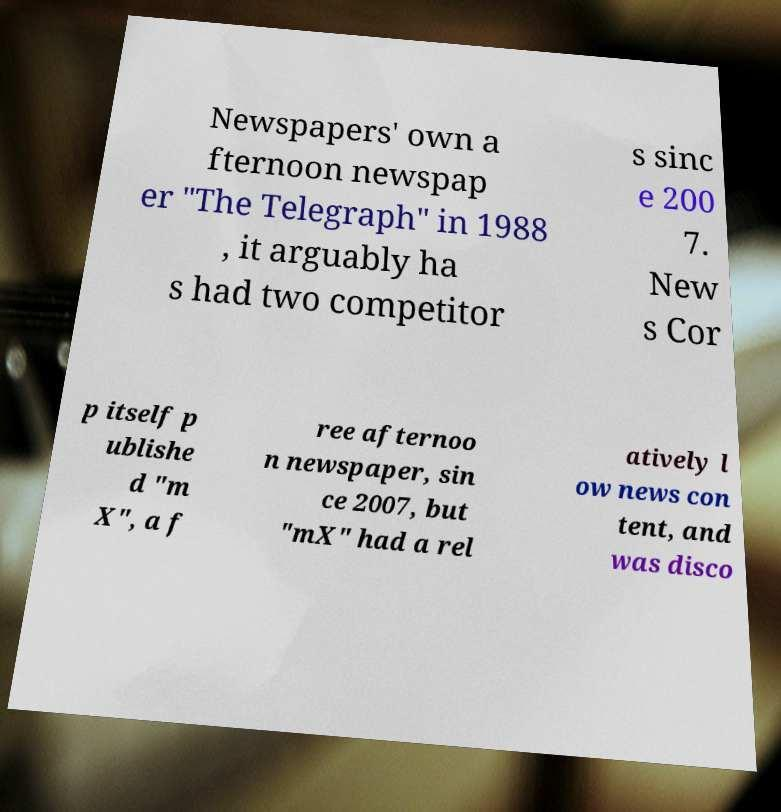Can you read and provide the text displayed in the image?This photo seems to have some interesting text. Can you extract and type it out for me? Newspapers' own a fternoon newspap er "The Telegraph" in 1988 , it arguably ha s had two competitor s sinc e 200 7. New s Cor p itself p ublishe d "m X", a f ree afternoo n newspaper, sin ce 2007, but "mX" had a rel atively l ow news con tent, and was disco 